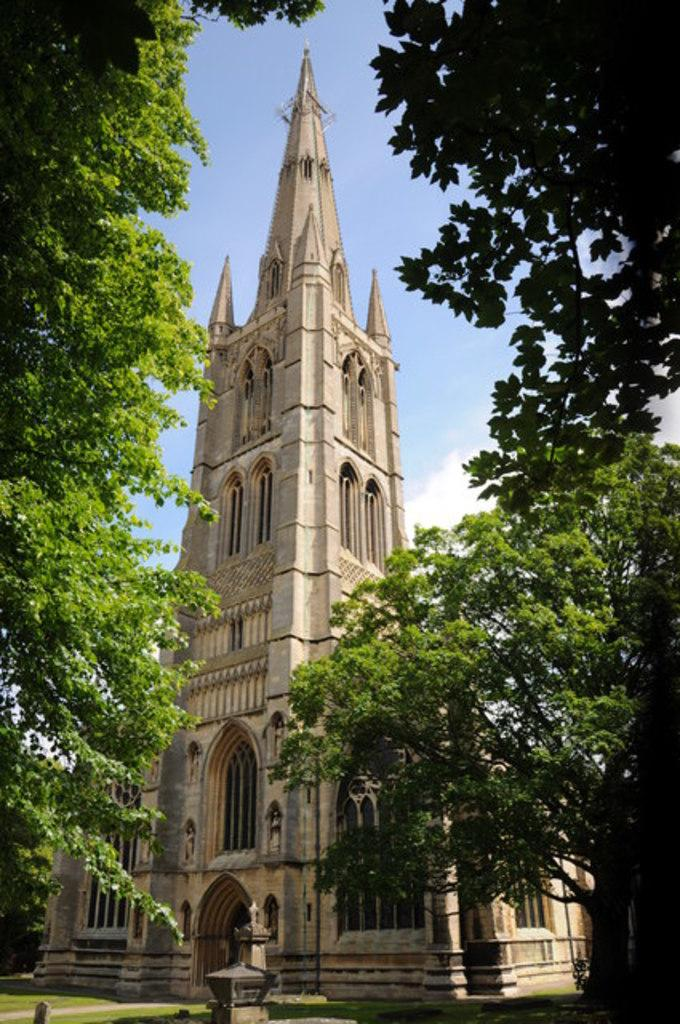What type of structure is present in the image? There is a building with windows in the image. What can be seen on the ground in the image? There is grass visible in the image. Are there any plants in the image? Yes, there are trees in the image. What is visible in the background of the image? The sky is visible in the image and appears cloudy. What type of prose is being recited by the judge in the image? There is no judge or prose present in the image; it features a building, grass, trees, and a cloudy sky. How many visitors can be seen in the image? There are no visitors present in the image. 